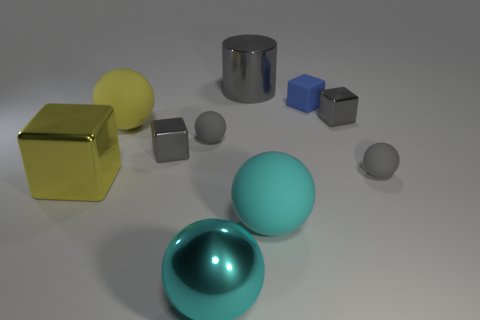Do the blue cube that is on the right side of the big gray metallic object and the metallic object that is left of the yellow ball have the same size? no 